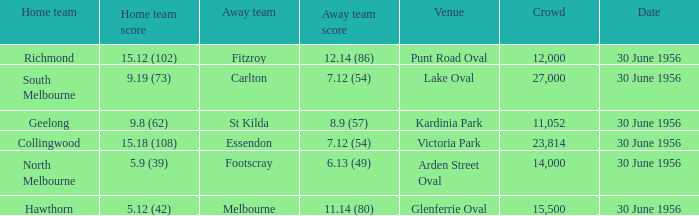What away team has a home team score of 15.18 (108)? Essendon. 